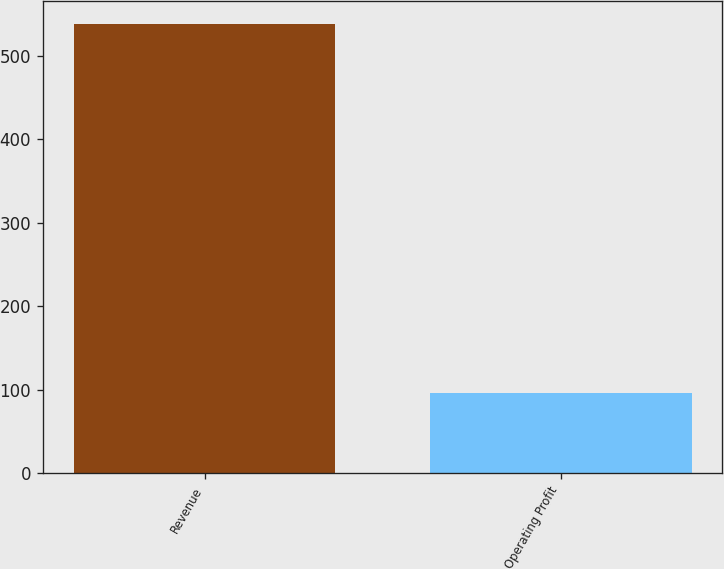Convert chart to OTSL. <chart><loc_0><loc_0><loc_500><loc_500><bar_chart><fcel>Revenue<fcel>Operating Profit<nl><fcel>538<fcel>96.1<nl></chart> 